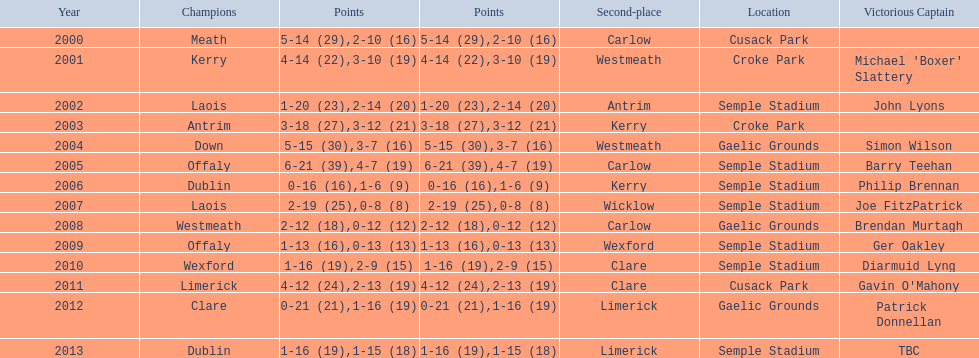Who was the first winner in 2013? Dublin. 